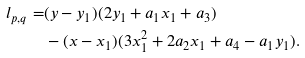Convert formula to latex. <formula><loc_0><loc_0><loc_500><loc_500>l _ { p , q } = & ( y - y _ { 1 } ) ( 2 y _ { 1 } + a _ { 1 } x _ { 1 } + a _ { 3 } ) \\ & - ( x - x _ { 1 } ) ( 3 x _ { 1 } ^ { 2 } + 2 a _ { 2 } x _ { 1 } + a _ { 4 } - a _ { 1 } y _ { 1 } ) .</formula> 